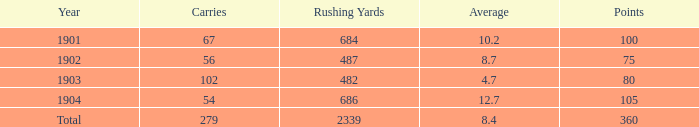Would you be able to parse every entry in this table? {'header': ['Year', 'Carries', 'Rushing Yards', 'Average', 'Points'], 'rows': [['1901', '67', '684', '10.2', '100'], ['1902', '56', '487', '8.7', '75'], ['1903', '102', '482', '4.7', '80'], ['1904', '54', '686', '12.7', '105'], ['Total', '279', '2339', '8.4', '360']]} How many carries have an average under 8.7 and touchdowns of 72? 1.0. 